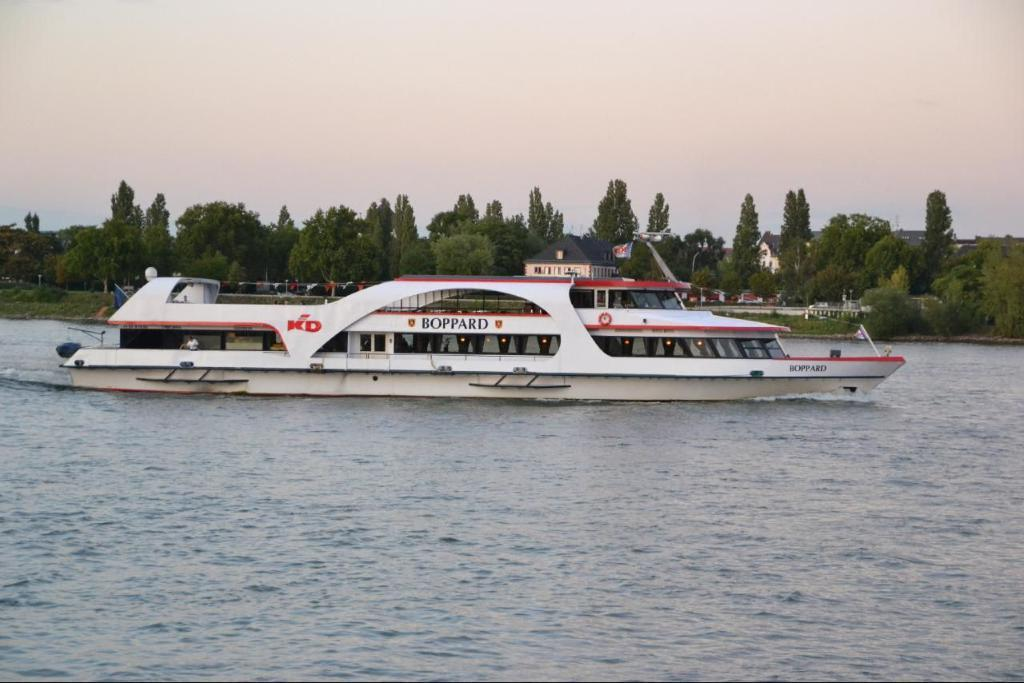What is the main subject of the image? The main subject of the image is a ship. Where is the ship located? The ship is on the water. What can be seen in the background of the image? There are trees, houses, and the sky visible in the background of the image. What type of chess piece is floating in the water next to the ship? There is no chess piece visible in the image; it only features a ship on the water. How much waste is being generated by the ship in the image? There is no information about waste generation in the image; it only shows a ship on the water. 